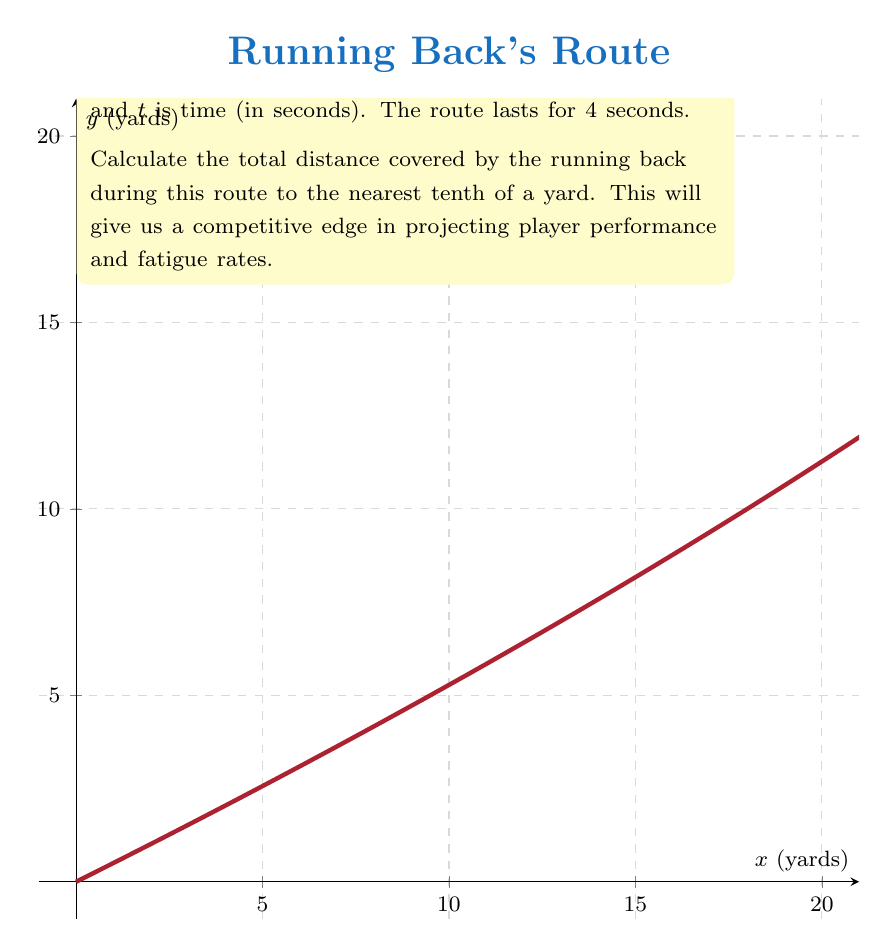Could you help me with this problem? To find the total distance covered, we need to calculate the arc length of the parametric curve. The formula for arc length is:

$$L = \int_a^b \sqrt{\left(\frac{dx}{dt}\right)^2 + \left(\frac{dy}{dt}\right)^2} dt$$

Step 1: Find $\frac{dx}{dt}$ and $\frac{dy}{dt}$
$$\frac{dx}{dt} = 10 - t$$
$$\frac{dy}{dt} = 5$$

Step 2: Substitute into the arc length formula
$$L = \int_0^4 \sqrt{(10-t)^2 + 5^2} dt$$

Step 3: Simplify under the square root
$$L = \int_0^4 \sqrt{100 - 20t + t^2 + 25} dt$$
$$L = \int_0^4 \sqrt{125 - 20t + t^2} dt$$

Step 4: This integral is difficult to solve analytically. We'll use numerical integration (Simpson's Rule with 4 subintervals) to approximate the result.

Let $f(t) = \sqrt{125 - 20t + t^2}$

Calculate $f(t)$ at $t = 0, 1, 2, 3, 4$:
$f(0) = \sqrt{125} \approx 11.18$
$f(1) = \sqrt{106} \approx 10.30$
$f(2) = \sqrt{89} \approx 9.43$
$f(3) = \sqrt{74} \approx 8.60$
$f(4) = \sqrt{61} \approx 7.81$

Apply Simpson's Rule:
$$L \approx \frac{4-0}{4 \cdot 3}[f(0) + 4f(1) + 2f(2) + 4f(3) + f(4)]$$
$$L \approx \frac{1}{3}[11.18 + 4(10.30) + 2(9.43) + 4(8.60) + 7.81]$$
$$L \approx \frac{1}{3}[11.18 + 41.20 + 18.86 + 34.40 + 7.81]$$
$$L \approx \frac{113.45}{3} \approx 37.8$$

Therefore, the total distance covered is approximately 37.8 yards.
Answer: 37.8 yards 